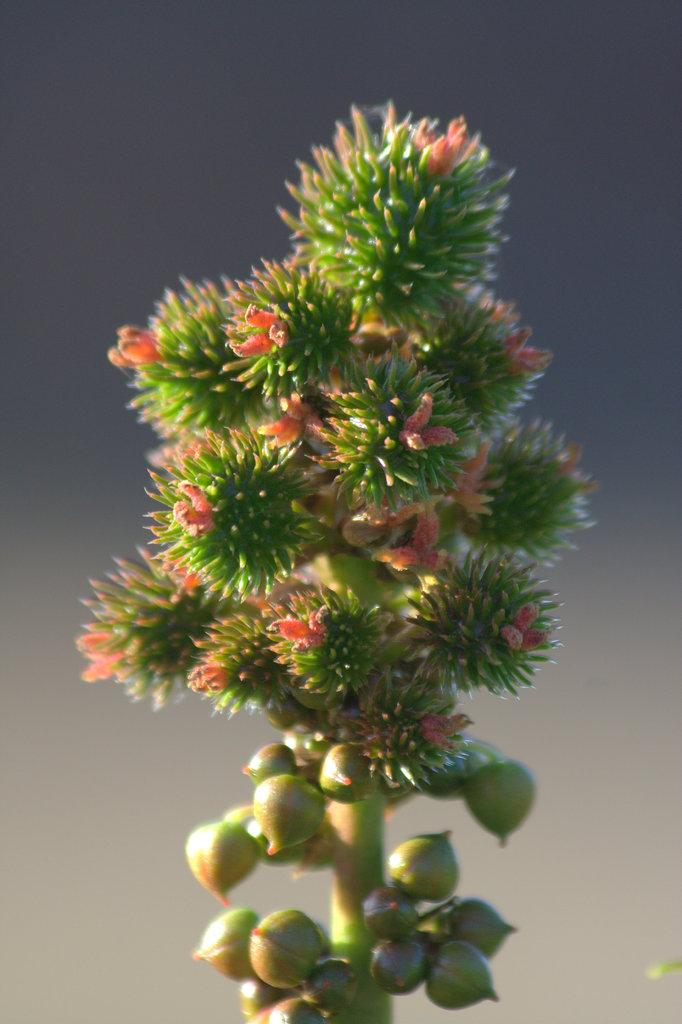What is the main subject of the image? The main subject of the image is a stem. What is attached to the stem? There are flowers and buds attached to the stem. How would you describe the background of the image? The background of the image is blurred. What type of nut is visible in the image? There is no nut present in the image; it features a stem with flowers and buds. How does the son contribute to the image? There is no son present in the image; it only features a stem, flowers, and buds. 